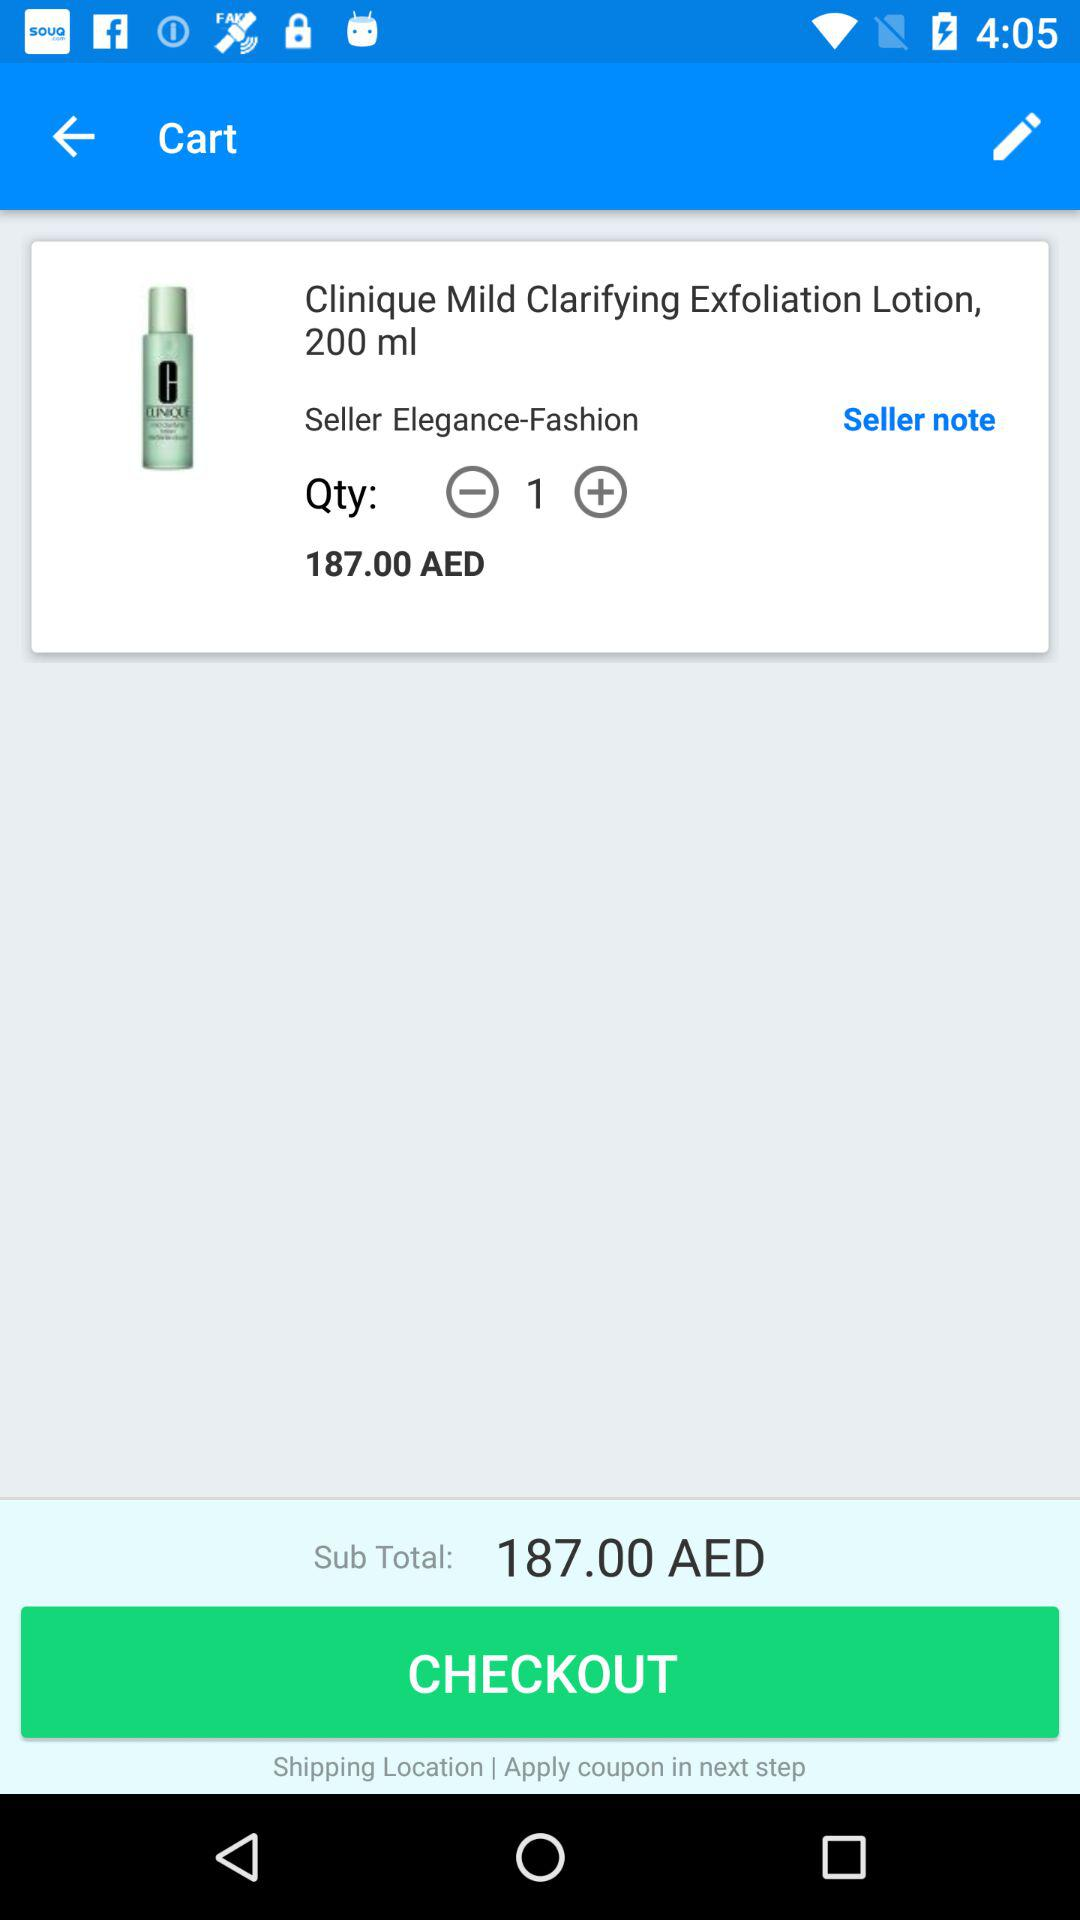How much is the total price of the items in the cart?
Answer the question using a single word or phrase. 187.00 AED 